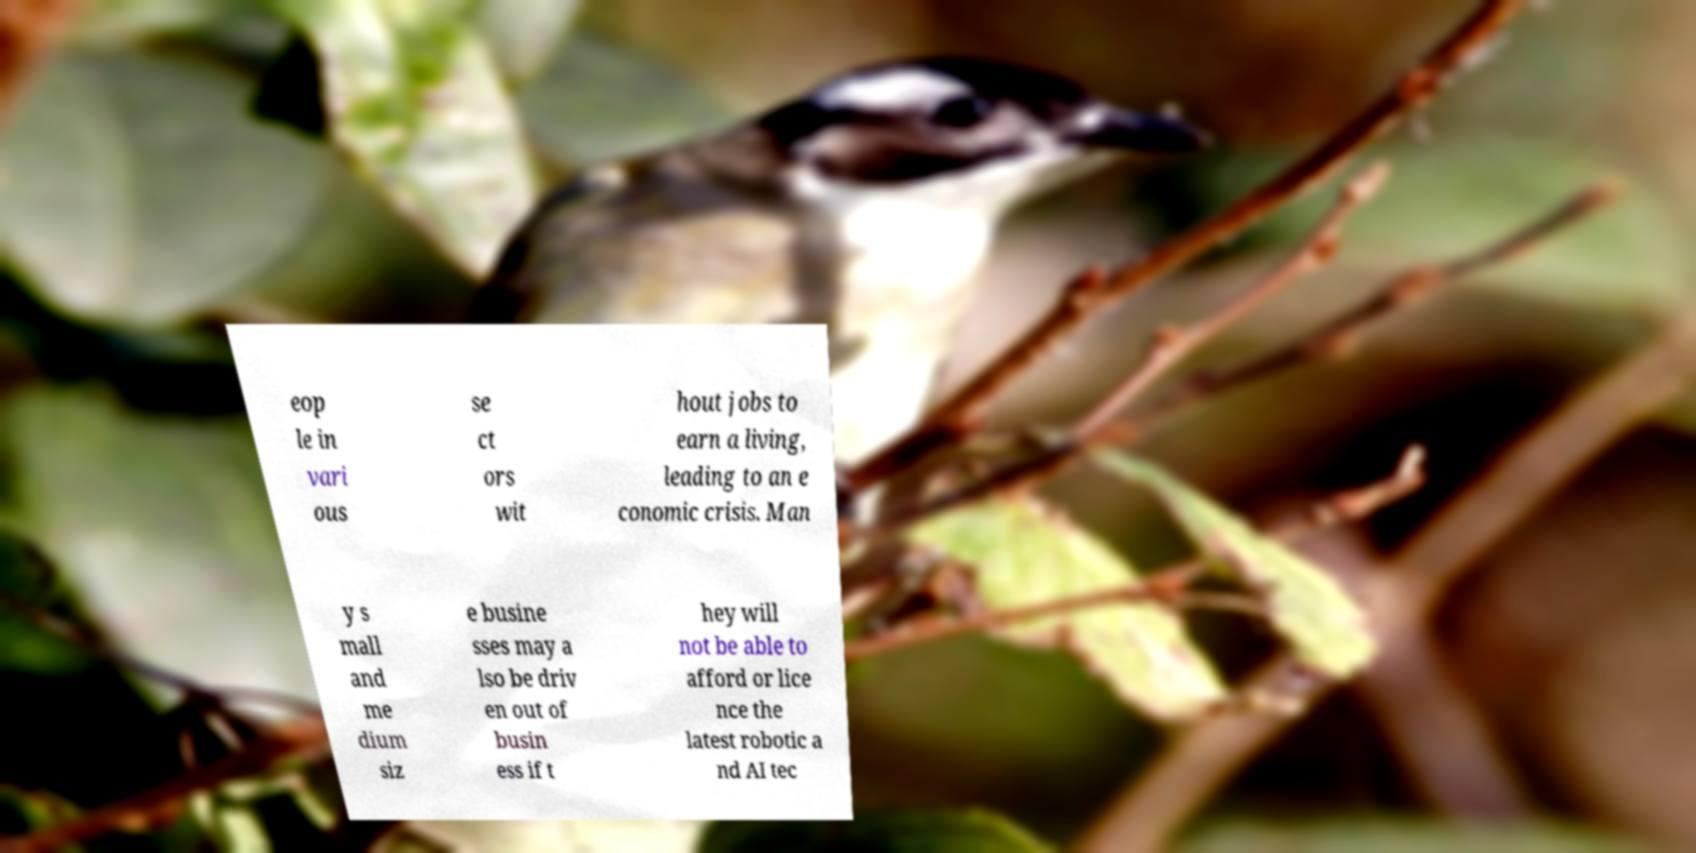Could you assist in decoding the text presented in this image and type it out clearly? eop le in vari ous se ct ors wit hout jobs to earn a living, leading to an e conomic crisis. Man y s mall and me dium siz e busine sses may a lso be driv en out of busin ess if t hey will not be able to afford or lice nce the latest robotic a nd AI tec 